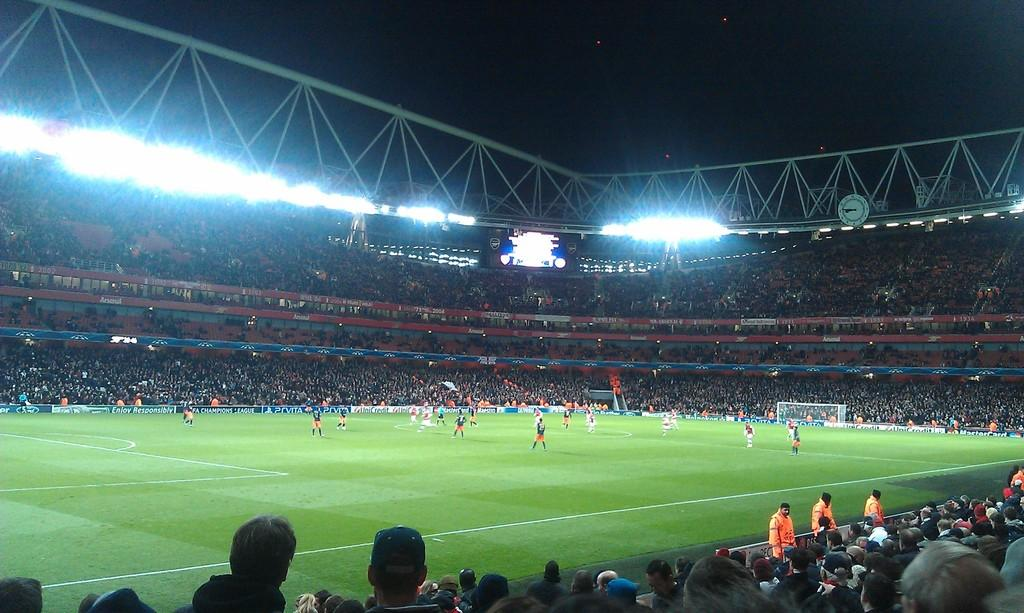Where was the image taken? The image was taken in a stadium. What activity is taking place in the center of the image? People are playing football in the center of the image. What can be seen in the background of the image? There is a crowd in the background of the image. What is visible at the top of the image? There are lights visible at the top of the image. Can you see any guns being used by the players in the image? No, there are no guns visible in the image. The players are playing football, which does not involve the use of guns. 